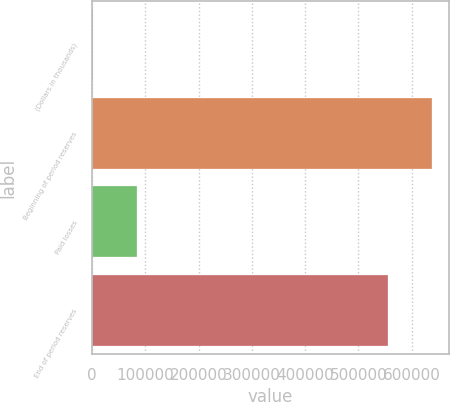Convert chart. <chart><loc_0><loc_0><loc_500><loc_500><bar_chart><fcel>(Dollars in thousands)<fcel>Beginning of period reserves<fcel>Paid losses<fcel>End of period reserves<nl><fcel>2010<fcel>638674<fcel>83884<fcel>554790<nl></chart> 